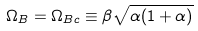<formula> <loc_0><loc_0><loc_500><loc_500>\Omega _ { B } = \Omega _ { B c } \equiv \beta \sqrt { \alpha ( 1 + \alpha ) }</formula> 